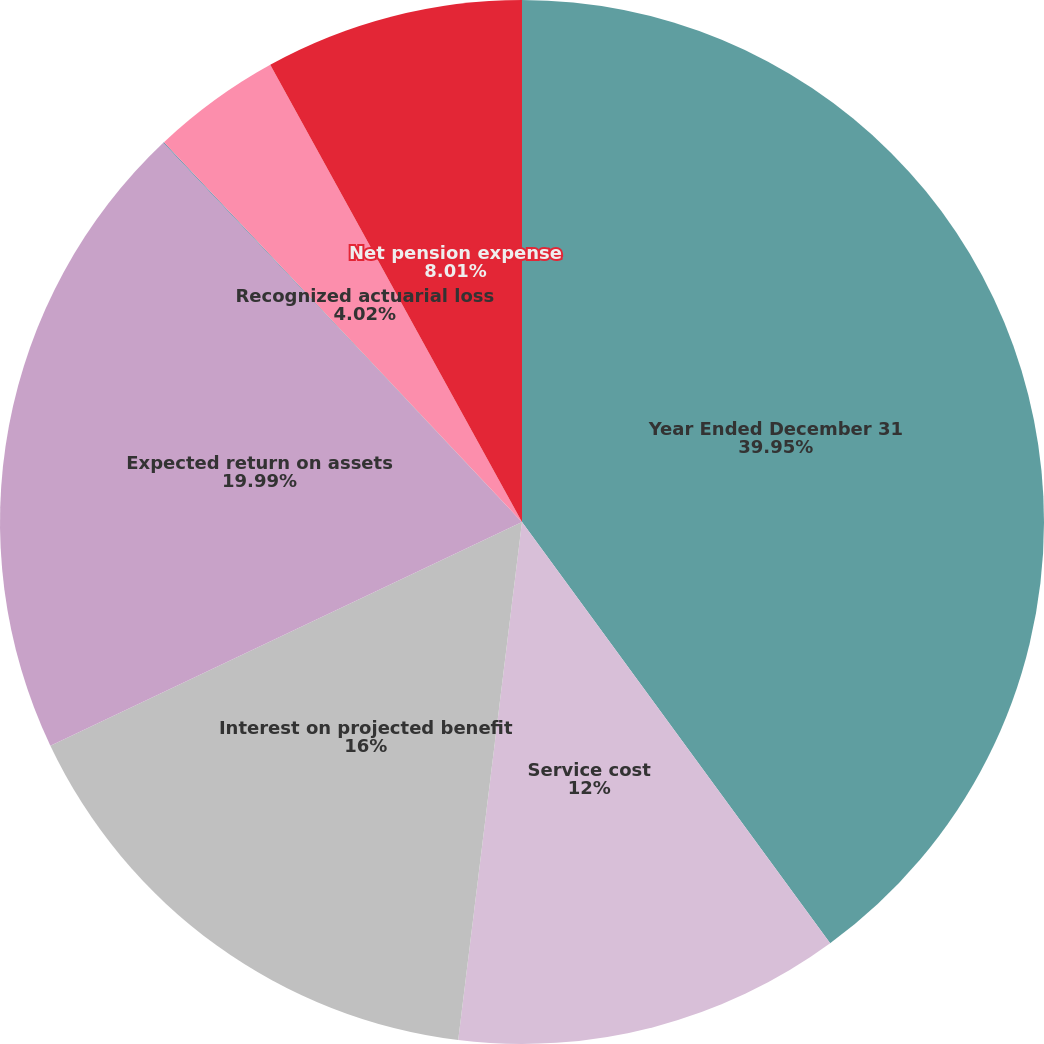<chart> <loc_0><loc_0><loc_500><loc_500><pie_chart><fcel>Year Ended December 31<fcel>Service cost<fcel>Interest on projected benefit<fcel>Expected return on assets<fcel>Amortization of prior service<fcel>Recognized actuarial loss<fcel>Net pension expense<nl><fcel>39.95%<fcel>12.0%<fcel>16.0%<fcel>19.99%<fcel>0.03%<fcel>4.02%<fcel>8.01%<nl></chart> 